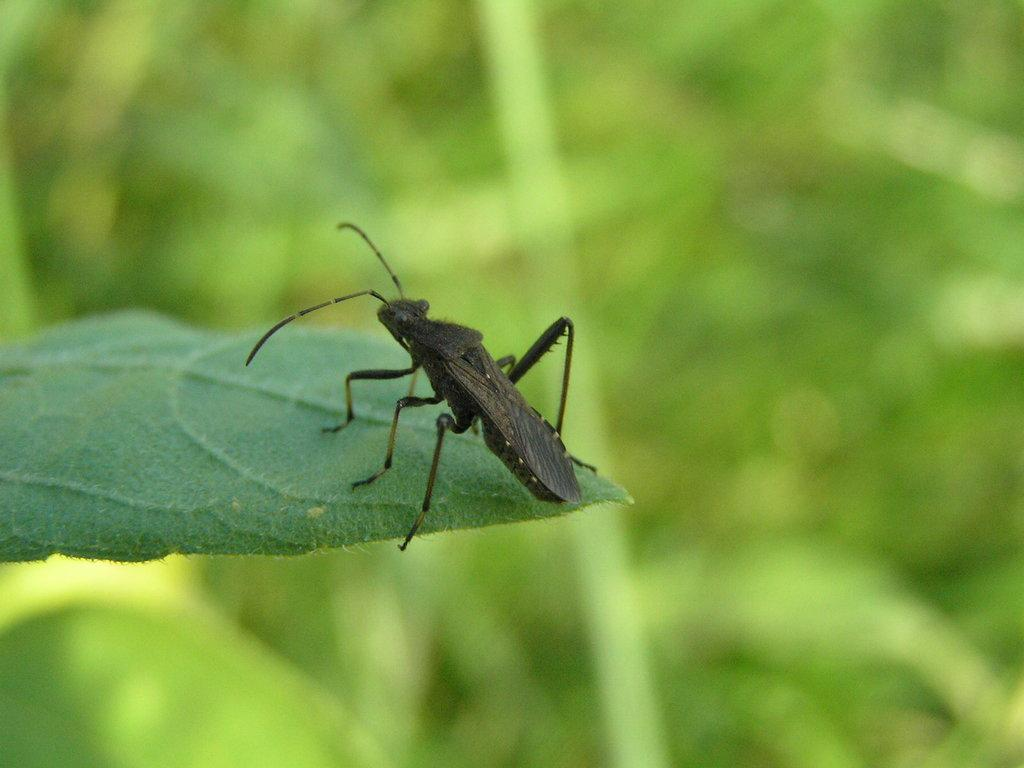What type of creature is present in the image? There is an insect in the image. Where is the insect located? The insect is on a leaf. What type of fruit is the insect holding in the image? There is no fruit present in the image, and the insect is not holding anything. 